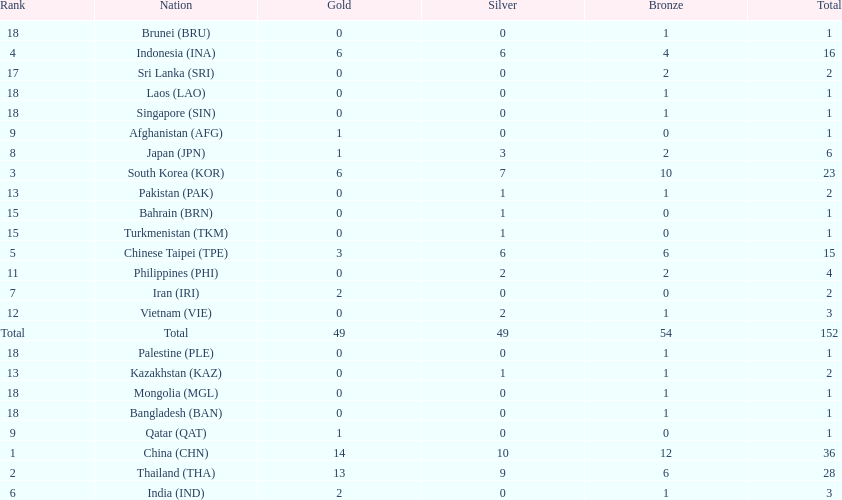Which countries won the same number of gold medals as japan? Afghanistan (AFG), Qatar (QAT). 